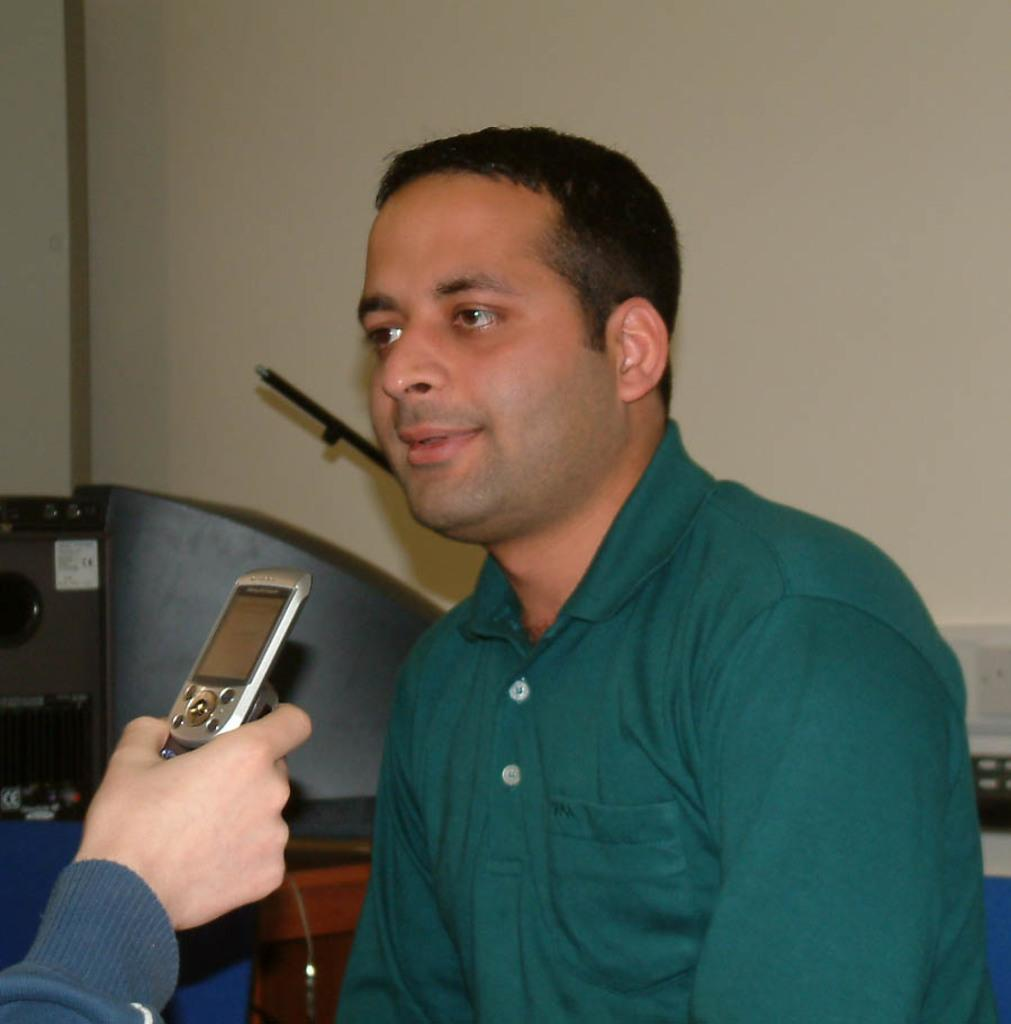Who is the main subject in the image? There is a man in the middle of the image. Can you describe the person in front of the man? The person in front of the man is holding a mobile. What can be seen in the background of the image? There is a wall in the background of the image. What type of sugar is being used to sweeten the skirt in the image? There is no sugar or skirt present in the image. 